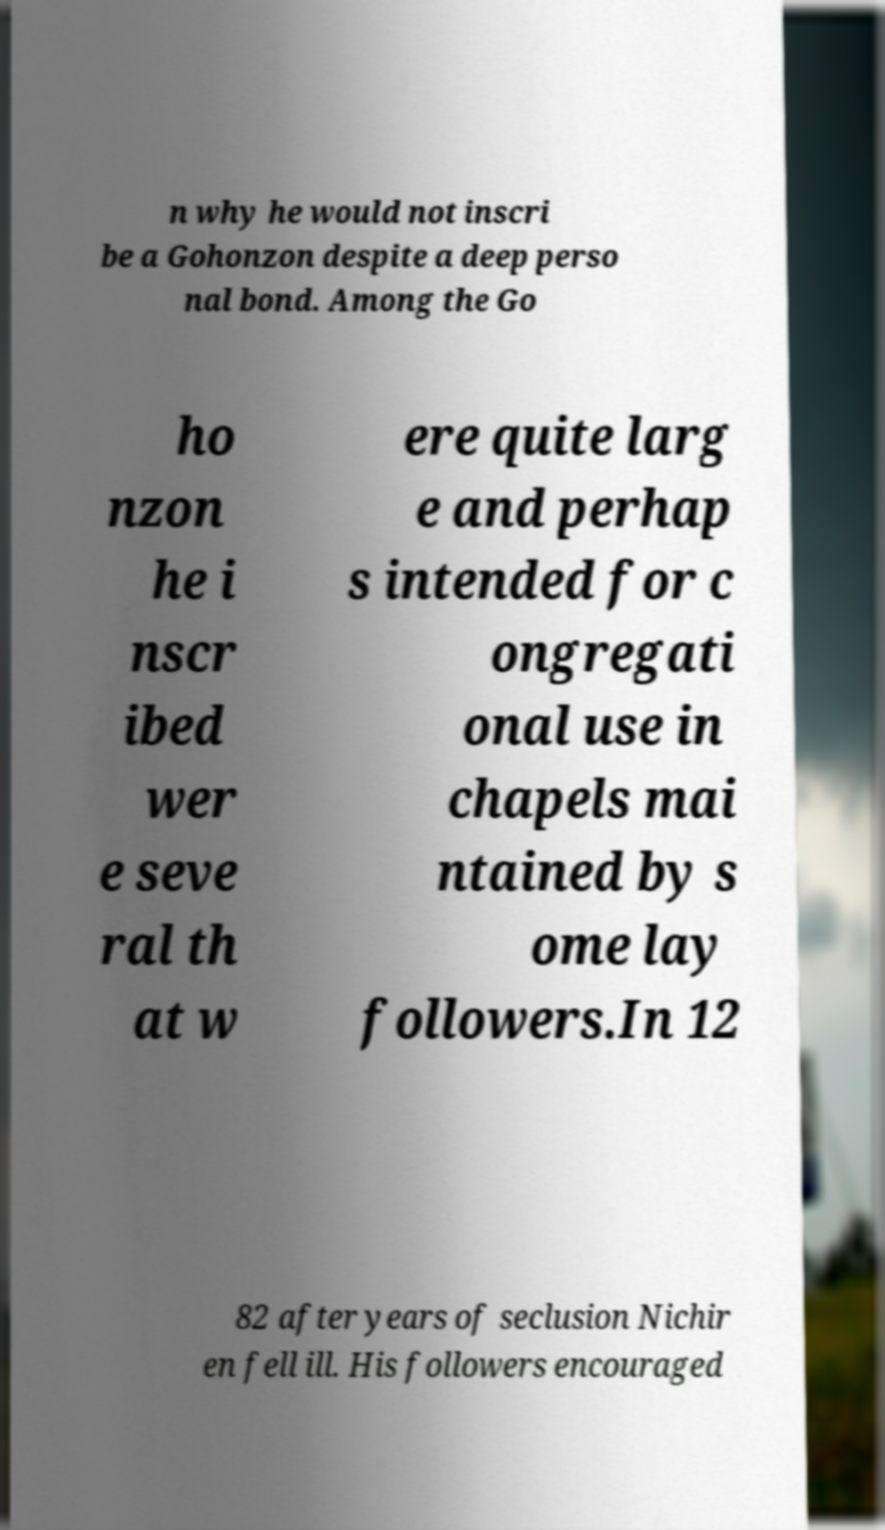Can you read and provide the text displayed in the image?This photo seems to have some interesting text. Can you extract and type it out for me? n why he would not inscri be a Gohonzon despite a deep perso nal bond. Among the Go ho nzon he i nscr ibed wer e seve ral th at w ere quite larg e and perhap s intended for c ongregati onal use in chapels mai ntained by s ome lay followers.In 12 82 after years of seclusion Nichir en fell ill. His followers encouraged 